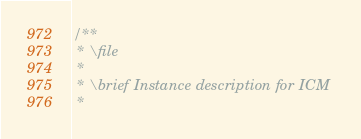Convert code to text. <code><loc_0><loc_0><loc_500><loc_500><_C_>/**
 * \file
 *
 * \brief Instance description for ICM
 *</code> 